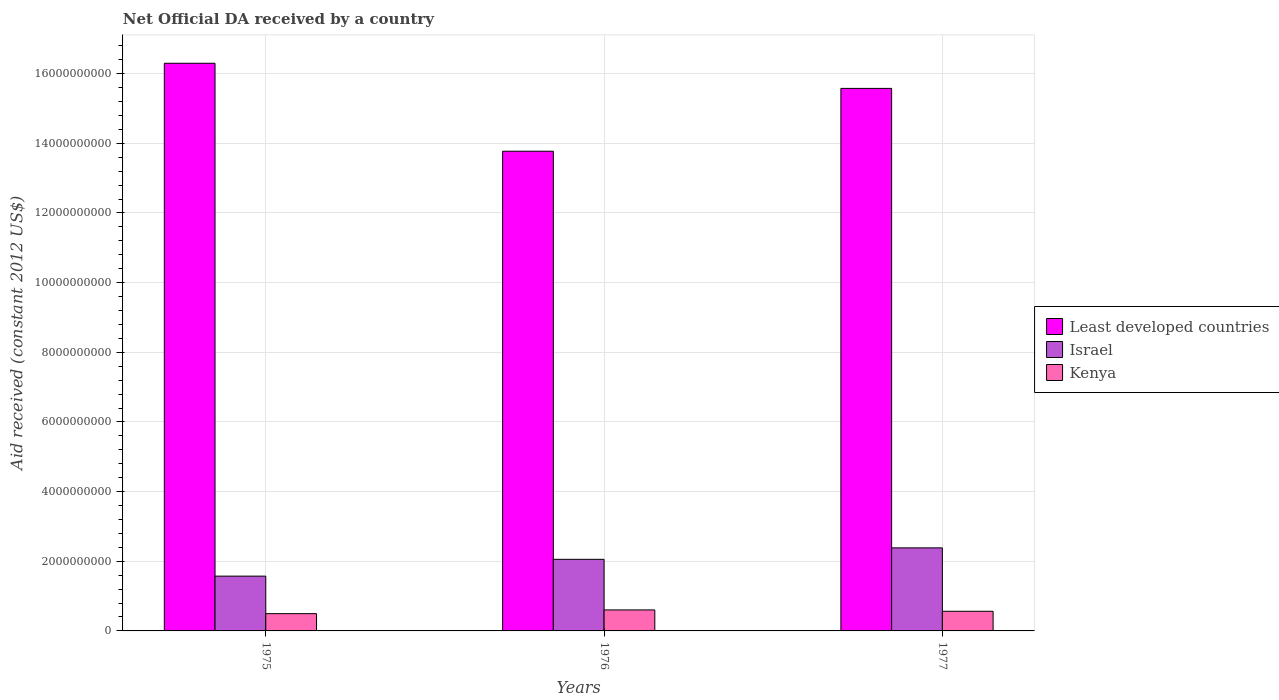How many groups of bars are there?
Your response must be concise. 3. Are the number of bars on each tick of the X-axis equal?
Provide a short and direct response. Yes. How many bars are there on the 3rd tick from the left?
Provide a succinct answer. 3. How many bars are there on the 1st tick from the right?
Offer a terse response. 3. What is the label of the 3rd group of bars from the left?
Offer a terse response. 1977. In how many cases, is the number of bars for a given year not equal to the number of legend labels?
Your response must be concise. 0. What is the net official development assistance aid received in Least developed countries in 1976?
Provide a succinct answer. 1.38e+1. Across all years, what is the maximum net official development assistance aid received in Least developed countries?
Your answer should be very brief. 1.63e+1. Across all years, what is the minimum net official development assistance aid received in Israel?
Offer a very short reply. 1.57e+09. In which year was the net official development assistance aid received in Israel maximum?
Give a very brief answer. 1977. In which year was the net official development assistance aid received in Least developed countries minimum?
Offer a very short reply. 1976. What is the total net official development assistance aid received in Israel in the graph?
Ensure brevity in your answer.  6.01e+09. What is the difference between the net official development assistance aid received in Least developed countries in 1976 and that in 1977?
Ensure brevity in your answer.  -1.80e+09. What is the difference between the net official development assistance aid received in Israel in 1977 and the net official development assistance aid received in Least developed countries in 1976?
Provide a short and direct response. -1.14e+1. What is the average net official development assistance aid received in Least developed countries per year?
Ensure brevity in your answer.  1.52e+1. In the year 1975, what is the difference between the net official development assistance aid received in Kenya and net official development assistance aid received in Israel?
Offer a very short reply. -1.08e+09. In how many years, is the net official development assistance aid received in Kenya greater than 1600000000 US$?
Your response must be concise. 0. What is the ratio of the net official development assistance aid received in Israel in 1975 to that in 1976?
Give a very brief answer. 0.77. Is the net official development assistance aid received in Kenya in 1975 less than that in 1977?
Make the answer very short. Yes. What is the difference between the highest and the second highest net official development assistance aid received in Least developed countries?
Give a very brief answer. 7.22e+08. What is the difference between the highest and the lowest net official development assistance aid received in Least developed countries?
Your answer should be compact. 2.53e+09. Is the sum of the net official development assistance aid received in Least developed countries in 1975 and 1977 greater than the maximum net official development assistance aid received in Israel across all years?
Provide a succinct answer. Yes. What does the 1st bar from the left in 1977 represents?
Your response must be concise. Least developed countries. What does the 1st bar from the right in 1977 represents?
Your answer should be very brief. Kenya. How many years are there in the graph?
Keep it short and to the point. 3. What is the difference between two consecutive major ticks on the Y-axis?
Your answer should be very brief. 2.00e+09. Does the graph contain any zero values?
Provide a succinct answer. No. Does the graph contain grids?
Your answer should be compact. Yes. How many legend labels are there?
Keep it short and to the point. 3. What is the title of the graph?
Offer a terse response. Net Official DA received by a country. What is the label or title of the X-axis?
Provide a short and direct response. Years. What is the label or title of the Y-axis?
Make the answer very short. Aid received (constant 2012 US$). What is the Aid received (constant 2012 US$) of Least developed countries in 1975?
Give a very brief answer. 1.63e+1. What is the Aid received (constant 2012 US$) of Israel in 1975?
Your response must be concise. 1.57e+09. What is the Aid received (constant 2012 US$) in Kenya in 1975?
Offer a terse response. 4.96e+08. What is the Aid received (constant 2012 US$) in Least developed countries in 1976?
Provide a short and direct response. 1.38e+1. What is the Aid received (constant 2012 US$) of Israel in 1976?
Make the answer very short. 2.06e+09. What is the Aid received (constant 2012 US$) of Kenya in 1976?
Make the answer very short. 6.03e+08. What is the Aid received (constant 2012 US$) in Least developed countries in 1977?
Provide a short and direct response. 1.56e+1. What is the Aid received (constant 2012 US$) in Israel in 1977?
Provide a short and direct response. 2.38e+09. What is the Aid received (constant 2012 US$) in Kenya in 1977?
Your answer should be very brief. 5.64e+08. Across all years, what is the maximum Aid received (constant 2012 US$) of Least developed countries?
Give a very brief answer. 1.63e+1. Across all years, what is the maximum Aid received (constant 2012 US$) in Israel?
Provide a succinct answer. 2.38e+09. Across all years, what is the maximum Aid received (constant 2012 US$) of Kenya?
Provide a short and direct response. 6.03e+08. Across all years, what is the minimum Aid received (constant 2012 US$) of Least developed countries?
Keep it short and to the point. 1.38e+1. Across all years, what is the minimum Aid received (constant 2012 US$) of Israel?
Offer a terse response. 1.57e+09. Across all years, what is the minimum Aid received (constant 2012 US$) of Kenya?
Give a very brief answer. 4.96e+08. What is the total Aid received (constant 2012 US$) in Least developed countries in the graph?
Your answer should be very brief. 4.57e+1. What is the total Aid received (constant 2012 US$) in Israel in the graph?
Give a very brief answer. 6.01e+09. What is the total Aid received (constant 2012 US$) of Kenya in the graph?
Ensure brevity in your answer.  1.66e+09. What is the difference between the Aid received (constant 2012 US$) in Least developed countries in 1975 and that in 1976?
Provide a succinct answer. 2.53e+09. What is the difference between the Aid received (constant 2012 US$) of Israel in 1975 and that in 1976?
Offer a very short reply. -4.83e+08. What is the difference between the Aid received (constant 2012 US$) in Kenya in 1975 and that in 1976?
Offer a very short reply. -1.07e+08. What is the difference between the Aid received (constant 2012 US$) in Least developed countries in 1975 and that in 1977?
Provide a short and direct response. 7.22e+08. What is the difference between the Aid received (constant 2012 US$) of Israel in 1975 and that in 1977?
Ensure brevity in your answer.  -8.11e+08. What is the difference between the Aid received (constant 2012 US$) in Kenya in 1975 and that in 1977?
Provide a short and direct response. -6.83e+07. What is the difference between the Aid received (constant 2012 US$) of Least developed countries in 1976 and that in 1977?
Make the answer very short. -1.80e+09. What is the difference between the Aid received (constant 2012 US$) of Israel in 1976 and that in 1977?
Keep it short and to the point. -3.29e+08. What is the difference between the Aid received (constant 2012 US$) of Kenya in 1976 and that in 1977?
Provide a short and direct response. 3.83e+07. What is the difference between the Aid received (constant 2012 US$) of Least developed countries in 1975 and the Aid received (constant 2012 US$) of Israel in 1976?
Keep it short and to the point. 1.42e+1. What is the difference between the Aid received (constant 2012 US$) in Least developed countries in 1975 and the Aid received (constant 2012 US$) in Kenya in 1976?
Provide a succinct answer. 1.57e+1. What is the difference between the Aid received (constant 2012 US$) in Israel in 1975 and the Aid received (constant 2012 US$) in Kenya in 1976?
Keep it short and to the point. 9.71e+08. What is the difference between the Aid received (constant 2012 US$) in Least developed countries in 1975 and the Aid received (constant 2012 US$) in Israel in 1977?
Ensure brevity in your answer.  1.39e+1. What is the difference between the Aid received (constant 2012 US$) of Least developed countries in 1975 and the Aid received (constant 2012 US$) of Kenya in 1977?
Provide a short and direct response. 1.57e+1. What is the difference between the Aid received (constant 2012 US$) of Israel in 1975 and the Aid received (constant 2012 US$) of Kenya in 1977?
Ensure brevity in your answer.  1.01e+09. What is the difference between the Aid received (constant 2012 US$) of Least developed countries in 1976 and the Aid received (constant 2012 US$) of Israel in 1977?
Keep it short and to the point. 1.14e+1. What is the difference between the Aid received (constant 2012 US$) in Least developed countries in 1976 and the Aid received (constant 2012 US$) in Kenya in 1977?
Ensure brevity in your answer.  1.32e+1. What is the difference between the Aid received (constant 2012 US$) of Israel in 1976 and the Aid received (constant 2012 US$) of Kenya in 1977?
Give a very brief answer. 1.49e+09. What is the average Aid received (constant 2012 US$) in Least developed countries per year?
Your answer should be very brief. 1.52e+1. What is the average Aid received (constant 2012 US$) of Israel per year?
Your response must be concise. 2.00e+09. What is the average Aid received (constant 2012 US$) of Kenya per year?
Give a very brief answer. 5.54e+08. In the year 1975, what is the difference between the Aid received (constant 2012 US$) of Least developed countries and Aid received (constant 2012 US$) of Israel?
Ensure brevity in your answer.  1.47e+1. In the year 1975, what is the difference between the Aid received (constant 2012 US$) of Least developed countries and Aid received (constant 2012 US$) of Kenya?
Your answer should be compact. 1.58e+1. In the year 1975, what is the difference between the Aid received (constant 2012 US$) in Israel and Aid received (constant 2012 US$) in Kenya?
Your answer should be very brief. 1.08e+09. In the year 1976, what is the difference between the Aid received (constant 2012 US$) in Least developed countries and Aid received (constant 2012 US$) in Israel?
Ensure brevity in your answer.  1.17e+1. In the year 1976, what is the difference between the Aid received (constant 2012 US$) in Least developed countries and Aid received (constant 2012 US$) in Kenya?
Keep it short and to the point. 1.32e+1. In the year 1976, what is the difference between the Aid received (constant 2012 US$) in Israel and Aid received (constant 2012 US$) in Kenya?
Offer a terse response. 1.45e+09. In the year 1977, what is the difference between the Aid received (constant 2012 US$) of Least developed countries and Aid received (constant 2012 US$) of Israel?
Provide a succinct answer. 1.32e+1. In the year 1977, what is the difference between the Aid received (constant 2012 US$) of Least developed countries and Aid received (constant 2012 US$) of Kenya?
Your answer should be compact. 1.50e+1. In the year 1977, what is the difference between the Aid received (constant 2012 US$) in Israel and Aid received (constant 2012 US$) in Kenya?
Keep it short and to the point. 1.82e+09. What is the ratio of the Aid received (constant 2012 US$) of Least developed countries in 1975 to that in 1976?
Your answer should be very brief. 1.18. What is the ratio of the Aid received (constant 2012 US$) in Israel in 1975 to that in 1976?
Offer a very short reply. 0.77. What is the ratio of the Aid received (constant 2012 US$) in Kenya in 1975 to that in 1976?
Ensure brevity in your answer.  0.82. What is the ratio of the Aid received (constant 2012 US$) of Least developed countries in 1975 to that in 1977?
Provide a succinct answer. 1.05. What is the ratio of the Aid received (constant 2012 US$) of Israel in 1975 to that in 1977?
Offer a terse response. 0.66. What is the ratio of the Aid received (constant 2012 US$) in Kenya in 1975 to that in 1977?
Ensure brevity in your answer.  0.88. What is the ratio of the Aid received (constant 2012 US$) of Least developed countries in 1976 to that in 1977?
Offer a terse response. 0.88. What is the ratio of the Aid received (constant 2012 US$) of Israel in 1976 to that in 1977?
Provide a short and direct response. 0.86. What is the ratio of the Aid received (constant 2012 US$) in Kenya in 1976 to that in 1977?
Your answer should be very brief. 1.07. What is the difference between the highest and the second highest Aid received (constant 2012 US$) in Least developed countries?
Your answer should be compact. 7.22e+08. What is the difference between the highest and the second highest Aid received (constant 2012 US$) in Israel?
Your answer should be compact. 3.29e+08. What is the difference between the highest and the second highest Aid received (constant 2012 US$) of Kenya?
Provide a succinct answer. 3.83e+07. What is the difference between the highest and the lowest Aid received (constant 2012 US$) of Least developed countries?
Your answer should be compact. 2.53e+09. What is the difference between the highest and the lowest Aid received (constant 2012 US$) of Israel?
Make the answer very short. 8.11e+08. What is the difference between the highest and the lowest Aid received (constant 2012 US$) in Kenya?
Your answer should be very brief. 1.07e+08. 